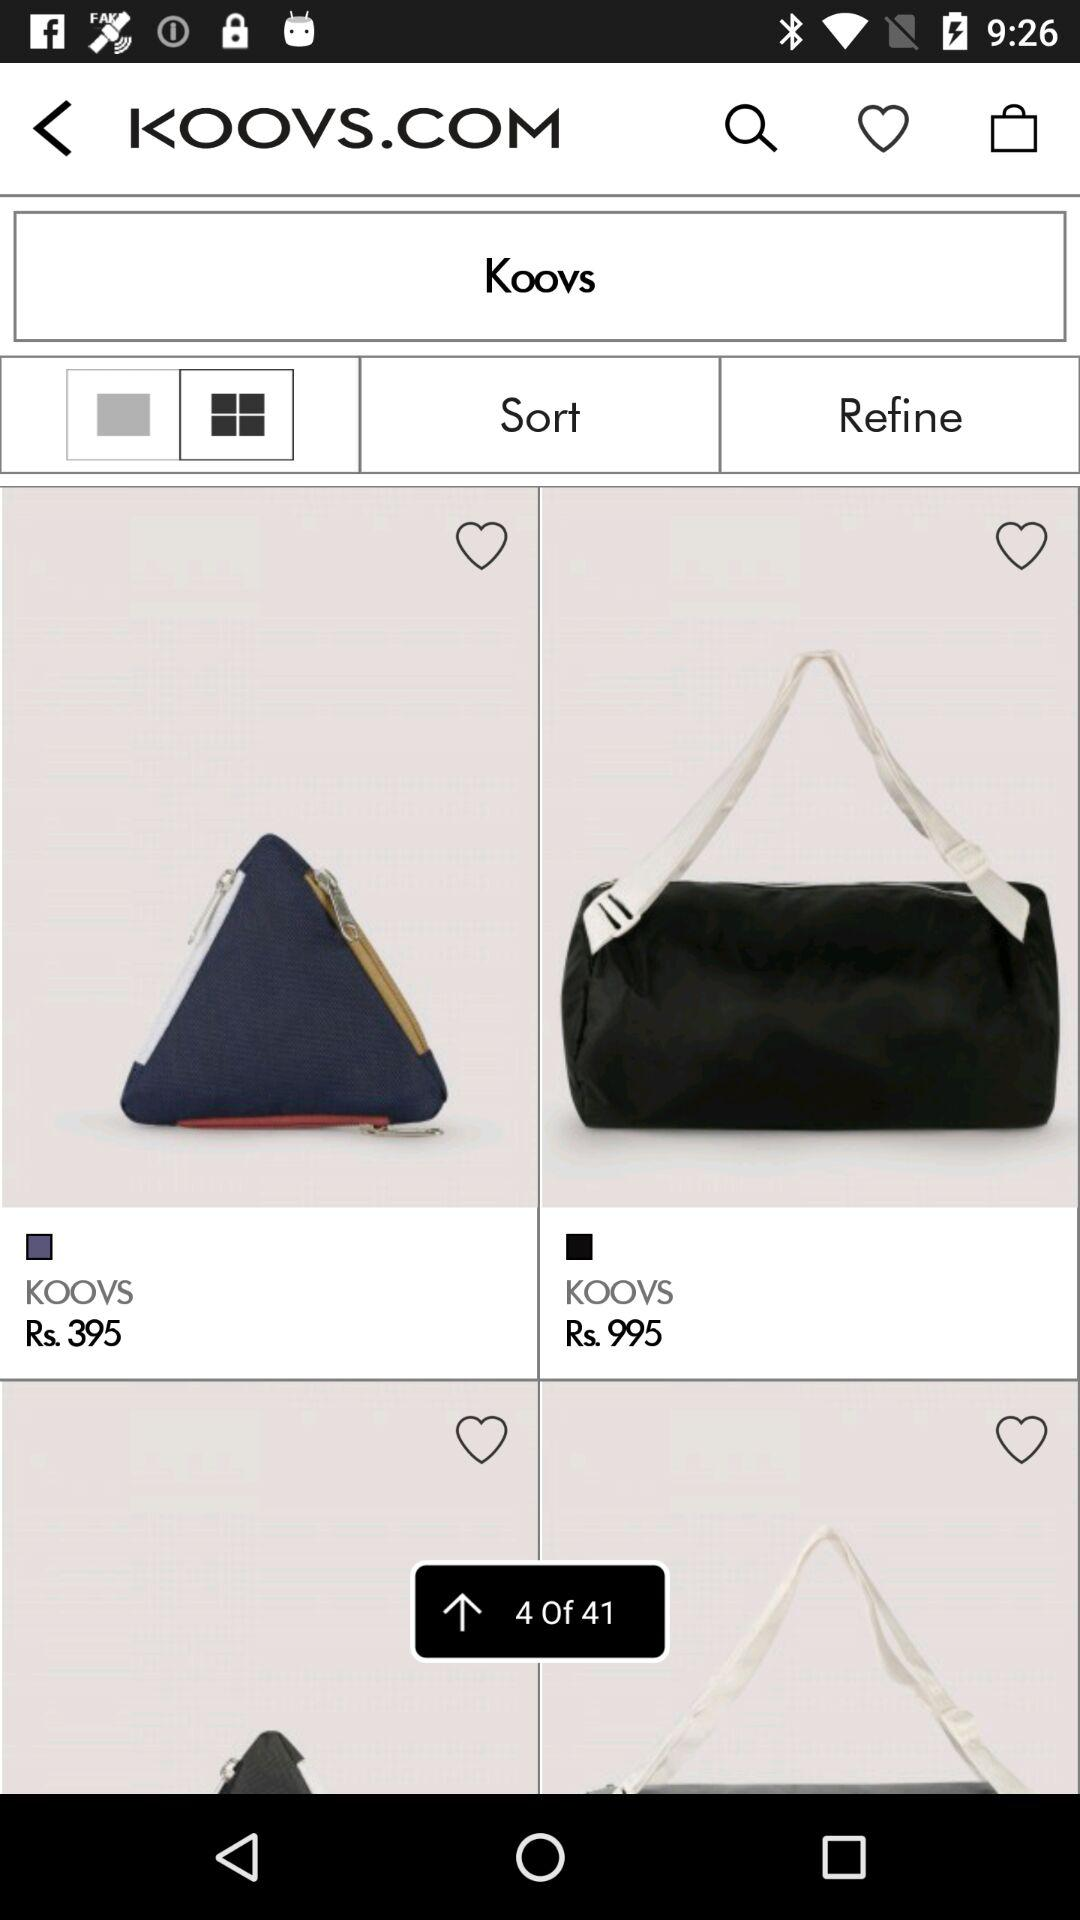I am at which page?
When the provided information is insufficient, respond with <no answer>. <no answer> 